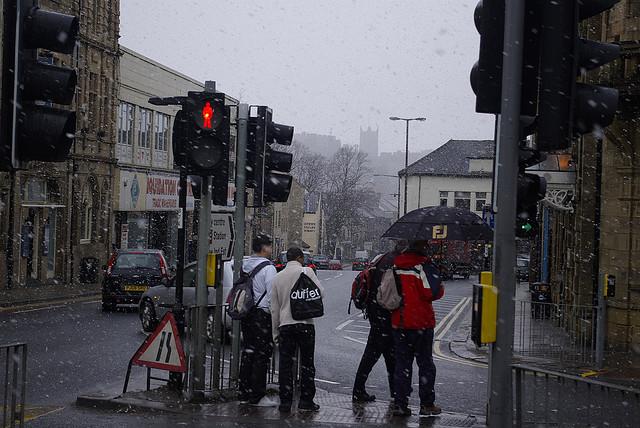Does the sign say to walk now?
Write a very short answer. No. Does the street show evidence of rain?
Short answer required. Yes. Are all the people waiting for the bus?
Concise answer only. No. What will happen when the light changes?
Short answer required. People will cross. What color is the umbrella?
Write a very short answer. Black. Where was this photo taken?
Short answer required. City. How many people are using the road?
Quick response, please. 4. Is this a street or an alley?
Quick response, please. Street. 